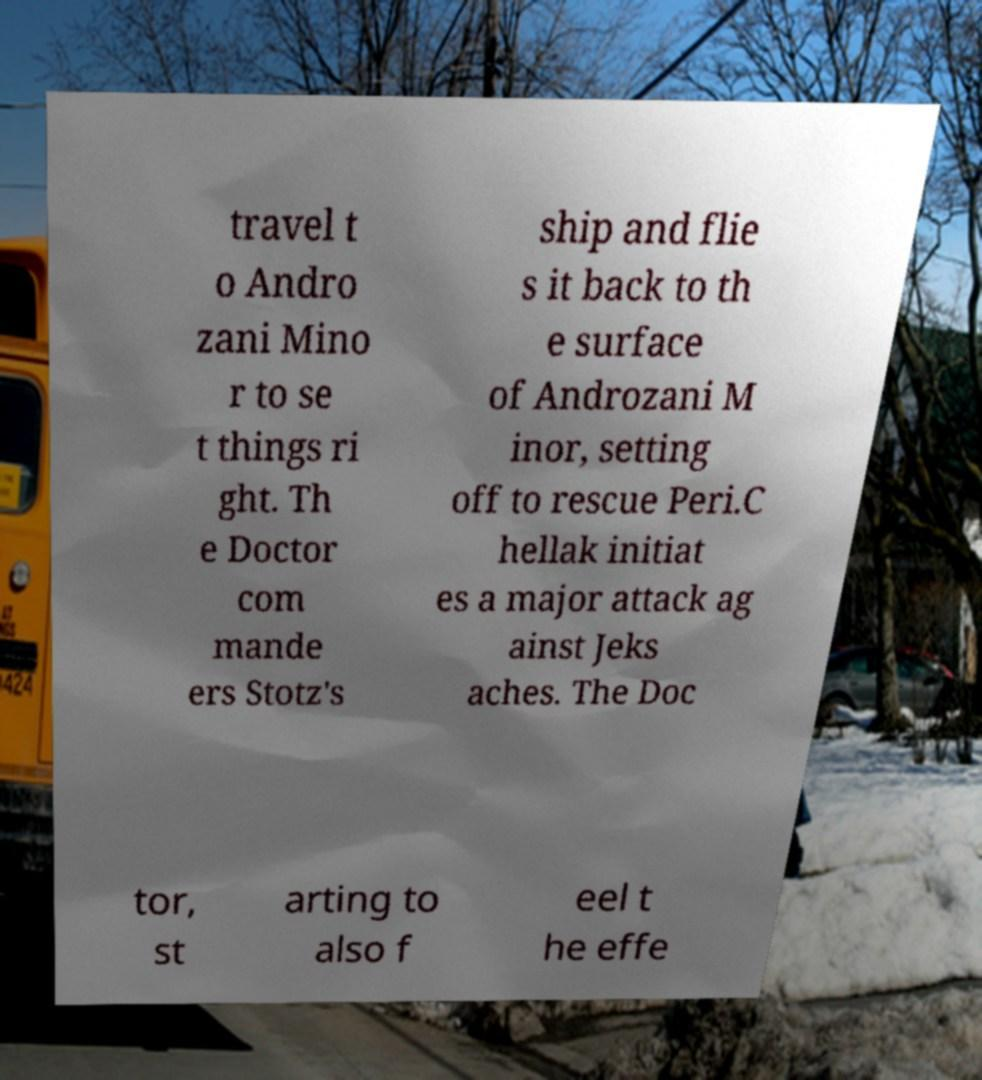I need the written content from this picture converted into text. Can you do that? travel t o Andro zani Mino r to se t things ri ght. Th e Doctor com mande ers Stotz's ship and flie s it back to th e surface of Androzani M inor, setting off to rescue Peri.C hellak initiat es a major attack ag ainst Jeks aches. The Doc tor, st arting to also f eel t he effe 